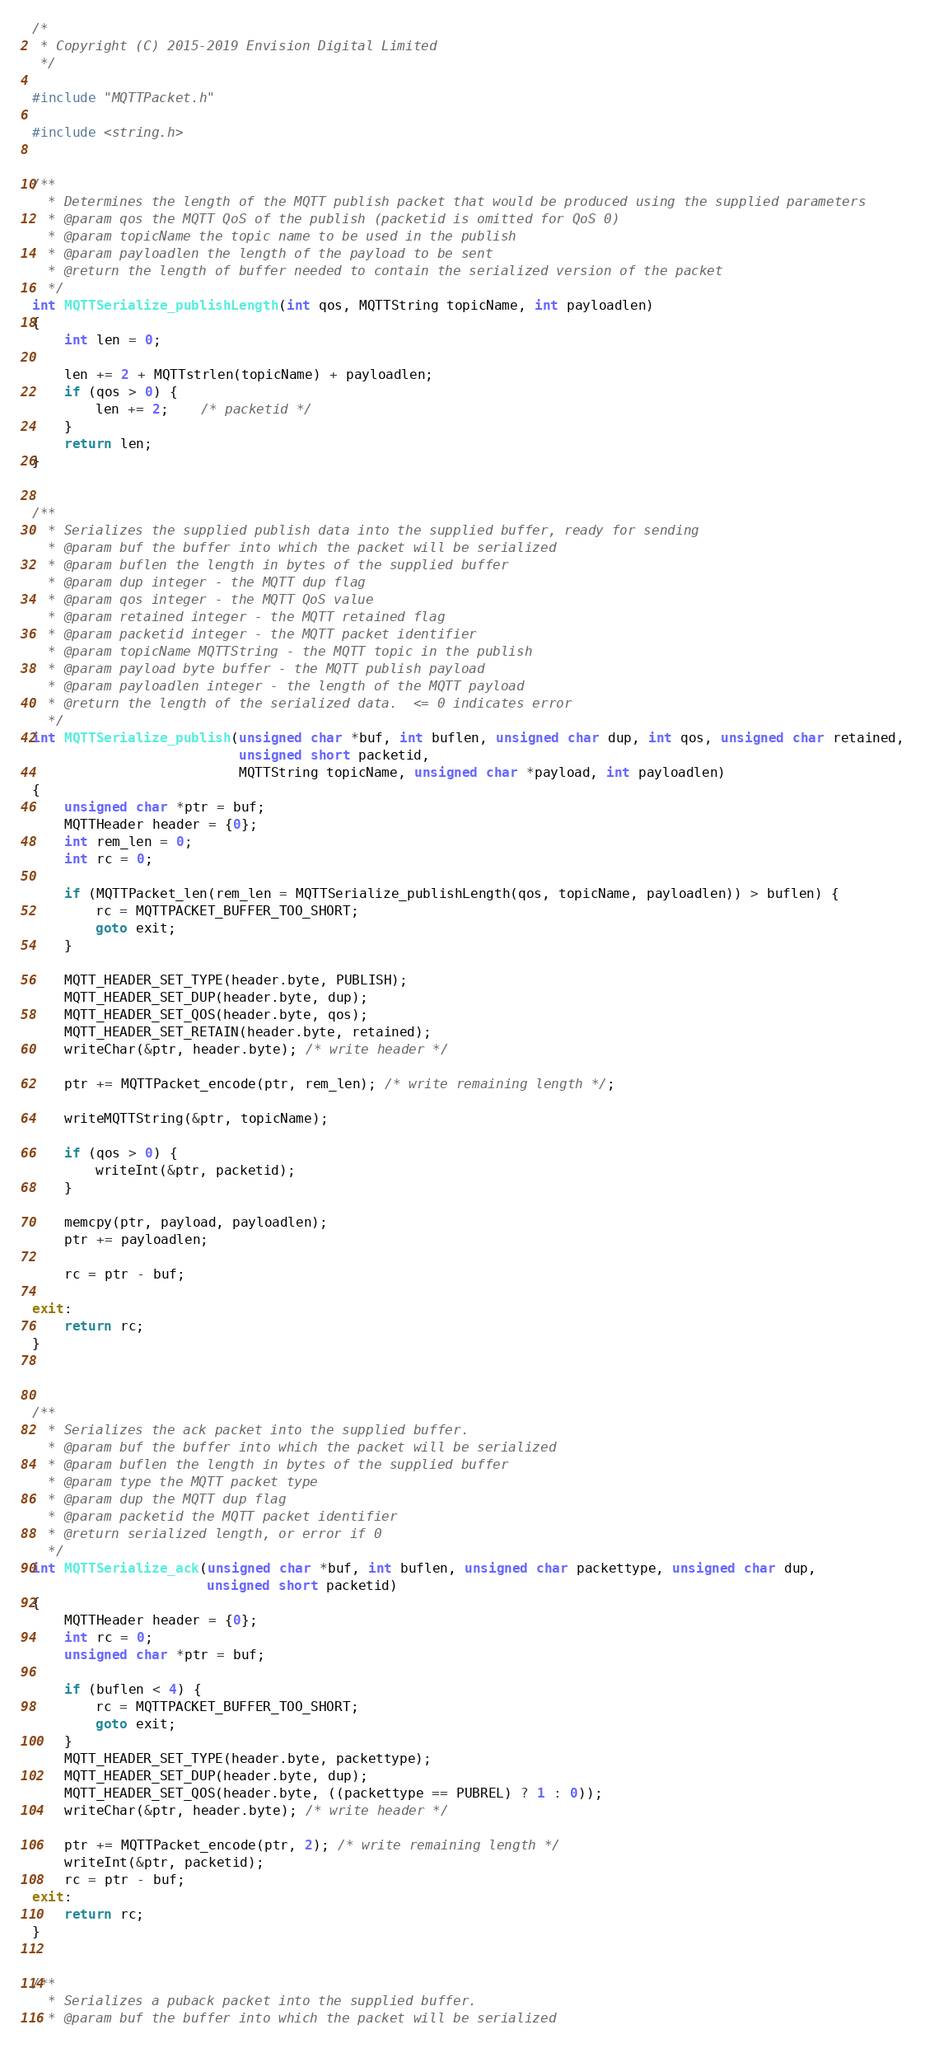Convert code to text. <code><loc_0><loc_0><loc_500><loc_500><_C_>/*
 * Copyright (C) 2015-2019 Envision Digital Limited
 */

#include "MQTTPacket.h"

#include <string.h>


/**
  * Determines the length of the MQTT publish packet that would be produced using the supplied parameters
  * @param qos the MQTT QoS of the publish (packetid is omitted for QoS 0)
  * @param topicName the topic name to be used in the publish
  * @param payloadlen the length of the payload to be sent
  * @return the length of buffer needed to contain the serialized version of the packet
  */
int MQTTSerialize_publishLength(int qos, MQTTString topicName, int payloadlen)
{
    int len = 0;

    len += 2 + MQTTstrlen(topicName) + payloadlen;
    if (qos > 0) {
        len += 2;    /* packetid */
    }
    return len;
}


/**
  * Serializes the supplied publish data into the supplied buffer, ready for sending
  * @param buf the buffer into which the packet will be serialized
  * @param buflen the length in bytes of the supplied buffer
  * @param dup integer - the MQTT dup flag
  * @param qos integer - the MQTT QoS value
  * @param retained integer - the MQTT retained flag
  * @param packetid integer - the MQTT packet identifier
  * @param topicName MQTTString - the MQTT topic in the publish
  * @param payload byte buffer - the MQTT publish payload
  * @param payloadlen integer - the length of the MQTT payload
  * @return the length of the serialized data.  <= 0 indicates error
  */
int MQTTSerialize_publish(unsigned char *buf, int buflen, unsigned char dup, int qos, unsigned char retained,
                          unsigned short packetid,
                          MQTTString topicName, unsigned char *payload, int payloadlen)
{
    unsigned char *ptr = buf;
    MQTTHeader header = {0};
    int rem_len = 0;
    int rc = 0;

    if (MQTTPacket_len(rem_len = MQTTSerialize_publishLength(qos, topicName, payloadlen)) > buflen) {
        rc = MQTTPACKET_BUFFER_TOO_SHORT;
        goto exit;
    }

    MQTT_HEADER_SET_TYPE(header.byte, PUBLISH);
    MQTT_HEADER_SET_DUP(header.byte, dup);
    MQTT_HEADER_SET_QOS(header.byte, qos);
    MQTT_HEADER_SET_RETAIN(header.byte, retained);
    writeChar(&ptr, header.byte); /* write header */

    ptr += MQTTPacket_encode(ptr, rem_len); /* write remaining length */;

    writeMQTTString(&ptr, topicName);

    if (qos > 0) {
        writeInt(&ptr, packetid);
    }

    memcpy(ptr, payload, payloadlen);
    ptr += payloadlen;

    rc = ptr - buf;

exit:
    return rc;
}



/**
  * Serializes the ack packet into the supplied buffer.
  * @param buf the buffer into which the packet will be serialized
  * @param buflen the length in bytes of the supplied buffer
  * @param type the MQTT packet type
  * @param dup the MQTT dup flag
  * @param packetid the MQTT packet identifier
  * @return serialized length, or error if 0
  */
int MQTTSerialize_ack(unsigned char *buf, int buflen, unsigned char packettype, unsigned char dup,
                      unsigned short packetid)
{
    MQTTHeader header = {0};
    int rc = 0;
    unsigned char *ptr = buf;

    if (buflen < 4) {
        rc = MQTTPACKET_BUFFER_TOO_SHORT;
        goto exit;
    }
    MQTT_HEADER_SET_TYPE(header.byte, packettype);
    MQTT_HEADER_SET_DUP(header.byte, dup);
    MQTT_HEADER_SET_QOS(header.byte, ((packettype == PUBREL) ? 1 : 0));
    writeChar(&ptr, header.byte); /* write header */

    ptr += MQTTPacket_encode(ptr, 2); /* write remaining length */
    writeInt(&ptr, packetid);
    rc = ptr - buf;
exit:
    return rc;
}


/**
  * Serializes a puback packet into the supplied buffer.
  * @param buf the buffer into which the packet will be serialized</code> 